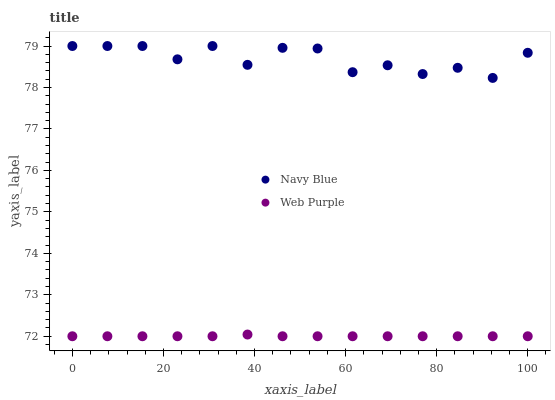Does Web Purple have the minimum area under the curve?
Answer yes or no. Yes. Does Navy Blue have the maximum area under the curve?
Answer yes or no. Yes. Does Web Purple have the maximum area under the curve?
Answer yes or no. No. Is Web Purple the smoothest?
Answer yes or no. Yes. Is Navy Blue the roughest?
Answer yes or no. Yes. Is Web Purple the roughest?
Answer yes or no. No. Does Web Purple have the lowest value?
Answer yes or no. Yes. Does Navy Blue have the highest value?
Answer yes or no. Yes. Does Web Purple have the highest value?
Answer yes or no. No. Is Web Purple less than Navy Blue?
Answer yes or no. Yes. Is Navy Blue greater than Web Purple?
Answer yes or no. Yes. Does Web Purple intersect Navy Blue?
Answer yes or no. No. 